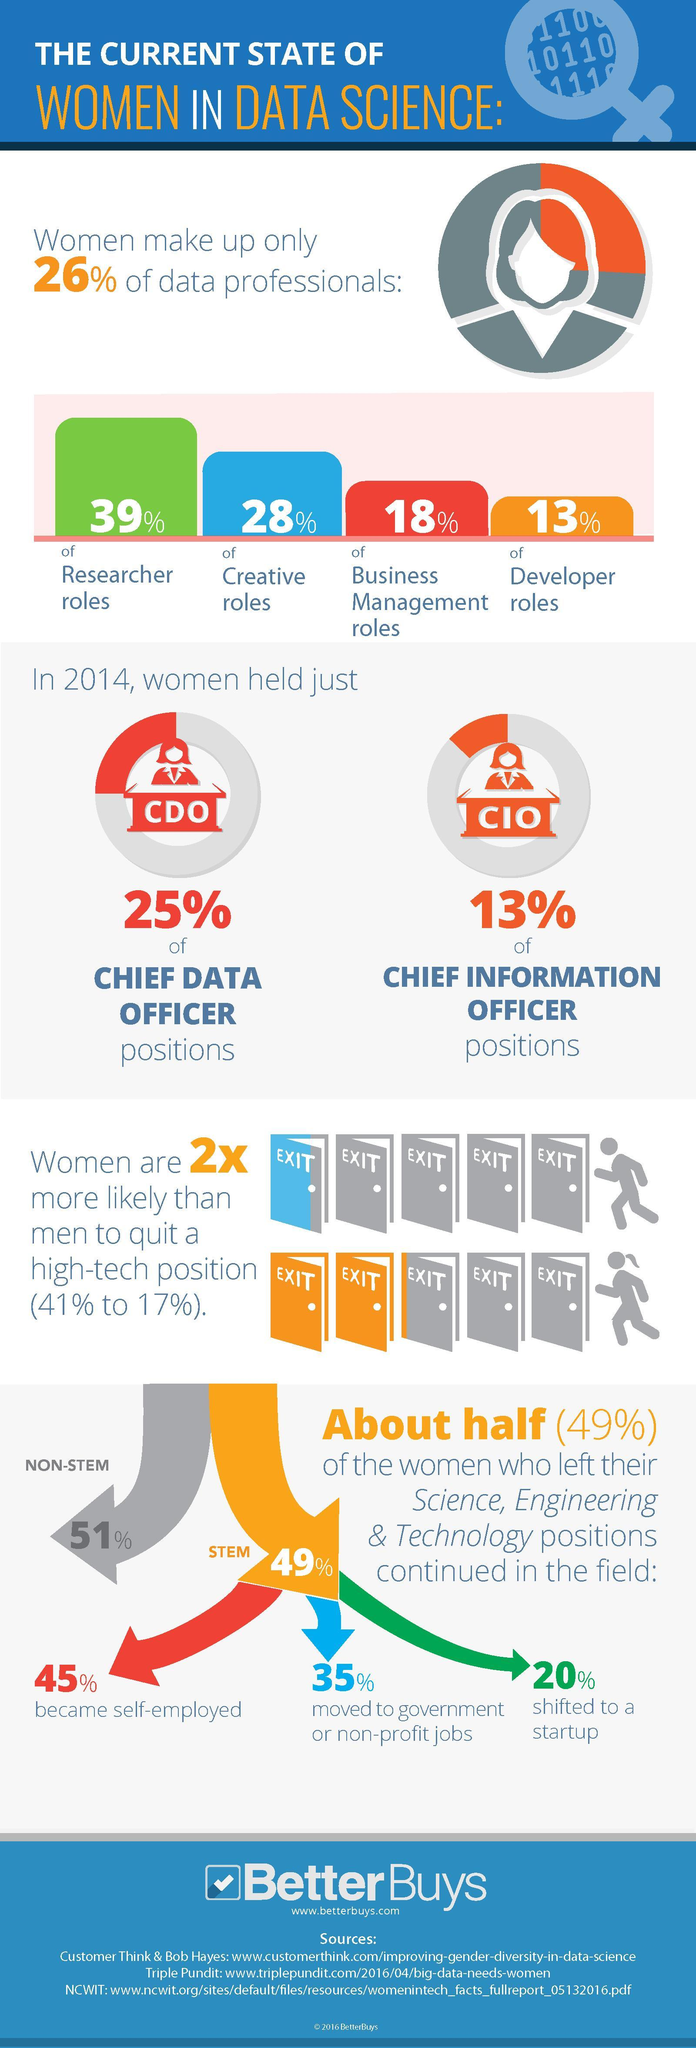What percentage of business management roles in data science was taken up by women?
Answer the question with a short phrase. 18% What percentage of the women who left their science, engineering & technology positions shifted to a startup? 20% What percentage of women held chief data positions in 2014? 25% What percentage of developer roles in data science was taken up by women? 13% What percentage of data professionals are men? 74% What percentage of the women who left their science, engineering & technology positions became self-employed? 45% 